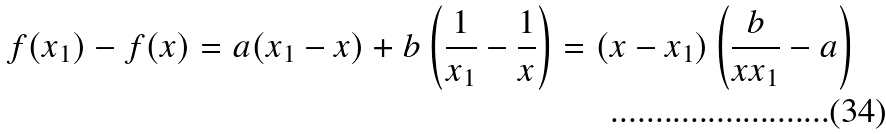Convert formula to latex. <formula><loc_0><loc_0><loc_500><loc_500>f ( x _ { 1 } ) - f ( x ) = a ( x _ { 1 } - x ) + b \left ( \frac { 1 } { x _ { 1 } } - \frac { 1 } { x } \right ) = ( x - x _ { 1 } ) \left ( \frac { b } { x x _ { 1 } } - a \right )</formula> 